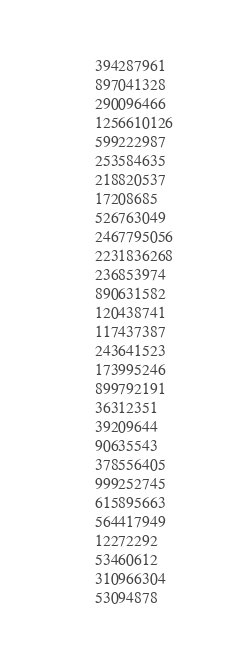<code> <loc_0><loc_0><loc_500><loc_500><_FORTRAN_>394287961
897041328
290096466
1256610126
599222987
253584635
218820537
17208685
526763049
2467795056
2231836268
236853974
890631582
120438741
117437387
243641523
173995246
899792191
36312351
39209644
90635543
378556405
999252745
615895663
564417949
12272292
53460612
310966304
53094878
</code> 